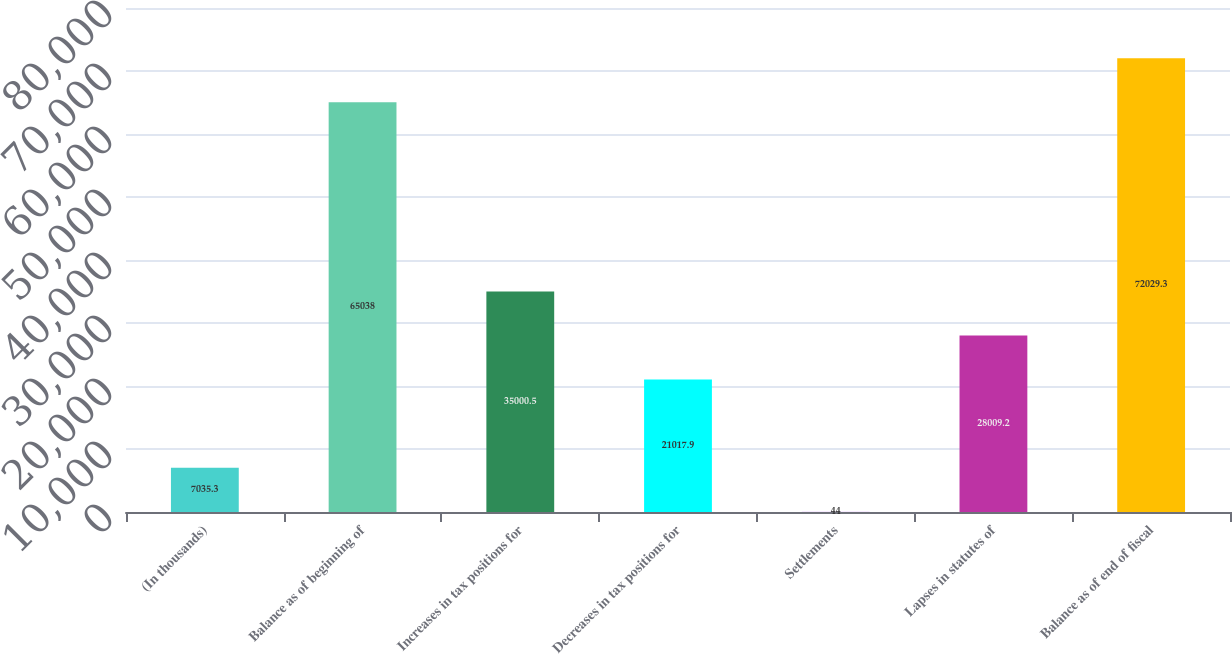<chart> <loc_0><loc_0><loc_500><loc_500><bar_chart><fcel>(In thousands)<fcel>Balance as of beginning of<fcel>Increases in tax positions for<fcel>Decreases in tax positions for<fcel>Settlements<fcel>Lapses in statutes of<fcel>Balance as of end of fiscal<nl><fcel>7035.3<fcel>65038<fcel>35000.5<fcel>21017.9<fcel>44<fcel>28009.2<fcel>72029.3<nl></chart> 